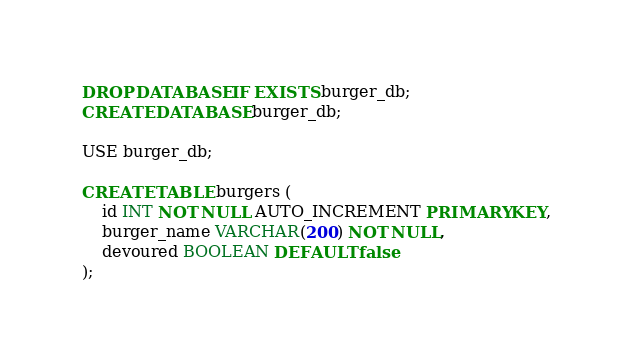Convert code to text. <code><loc_0><loc_0><loc_500><loc_500><_SQL_>DROP DATABASE IF EXISTS burger_db;
CREATE DATABASE burger_db;

USE burger_db;

CREATE TABLE burgers (
    id INT NOT NULL AUTO_INCREMENT PRIMARY KEY,
    burger_name VARCHAR(200) NOT NULL,
    devoured BOOLEAN DEFAULT false
);</code> 